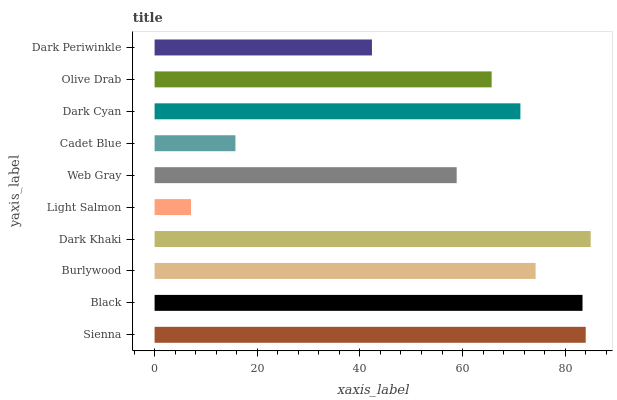Is Light Salmon the minimum?
Answer yes or no. Yes. Is Dark Khaki the maximum?
Answer yes or no. Yes. Is Black the minimum?
Answer yes or no. No. Is Black the maximum?
Answer yes or no. No. Is Sienna greater than Black?
Answer yes or no. Yes. Is Black less than Sienna?
Answer yes or no. Yes. Is Black greater than Sienna?
Answer yes or no. No. Is Sienna less than Black?
Answer yes or no. No. Is Dark Cyan the high median?
Answer yes or no. Yes. Is Olive Drab the low median?
Answer yes or no. Yes. Is Sienna the high median?
Answer yes or no. No. Is Light Salmon the low median?
Answer yes or no. No. 